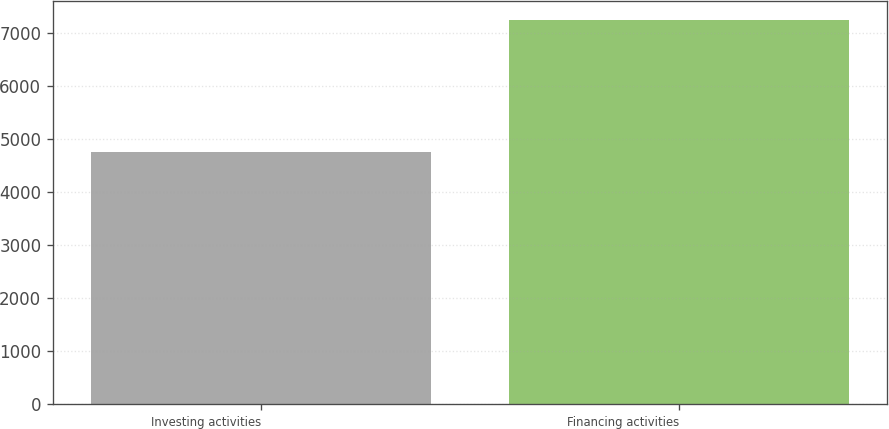<chart> <loc_0><loc_0><loc_500><loc_500><bar_chart><fcel>Investing activities<fcel>Financing activities<nl><fcel>4755<fcel>7246<nl></chart> 